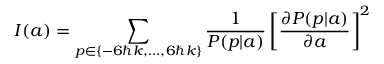<formula> <loc_0><loc_0><loc_500><loc_500>I ( a ) = \sum _ { p \in \{ - 6 \hbar { k } , \dots , 6 \hbar { k } \} } \frac { 1 } P ( p | a ) } \left [ \frac { \partial P ( p | a ) } { \partial a } \right ] ^ { 2 }</formula> 